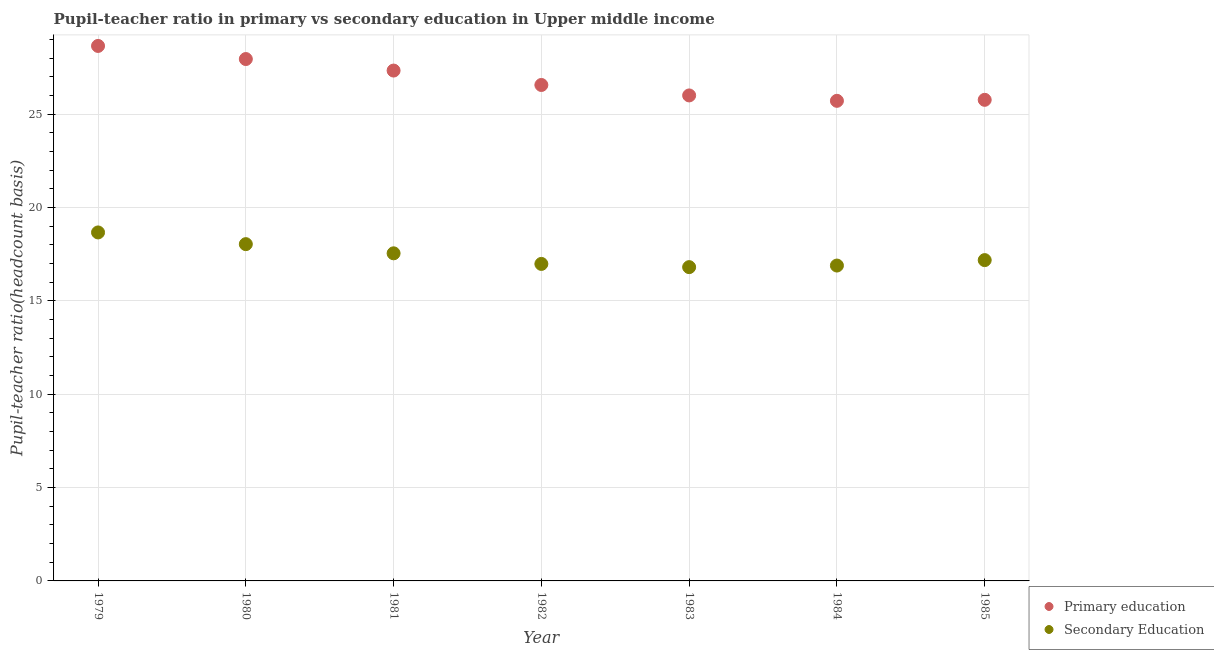How many different coloured dotlines are there?
Your answer should be very brief. 2. Is the number of dotlines equal to the number of legend labels?
Your response must be concise. Yes. What is the pupil-teacher ratio in primary education in 1984?
Keep it short and to the point. 25.72. Across all years, what is the maximum pupil teacher ratio on secondary education?
Your answer should be compact. 18.67. Across all years, what is the minimum pupil teacher ratio on secondary education?
Your answer should be very brief. 16.81. In which year was the pupil-teacher ratio in primary education maximum?
Keep it short and to the point. 1979. In which year was the pupil-teacher ratio in primary education minimum?
Offer a very short reply. 1984. What is the total pupil-teacher ratio in primary education in the graph?
Give a very brief answer. 188. What is the difference between the pupil-teacher ratio in primary education in 1983 and that in 1985?
Provide a short and direct response. 0.24. What is the difference between the pupil teacher ratio on secondary education in 1981 and the pupil-teacher ratio in primary education in 1984?
Make the answer very short. -8.17. What is the average pupil-teacher ratio in primary education per year?
Make the answer very short. 26.86. In the year 1983, what is the difference between the pupil-teacher ratio in primary education and pupil teacher ratio on secondary education?
Make the answer very short. 9.2. In how many years, is the pupil-teacher ratio in primary education greater than 16?
Your answer should be compact. 7. What is the ratio of the pupil-teacher ratio in primary education in 1979 to that in 1982?
Keep it short and to the point. 1.08. Is the pupil teacher ratio on secondary education in 1982 less than that in 1983?
Offer a terse response. No. What is the difference between the highest and the second highest pupil-teacher ratio in primary education?
Make the answer very short. 0.7. What is the difference between the highest and the lowest pupil teacher ratio on secondary education?
Give a very brief answer. 1.86. How many dotlines are there?
Offer a terse response. 2. How many years are there in the graph?
Provide a succinct answer. 7. Does the graph contain grids?
Your answer should be very brief. Yes. Where does the legend appear in the graph?
Offer a very short reply. Bottom right. What is the title of the graph?
Offer a terse response. Pupil-teacher ratio in primary vs secondary education in Upper middle income. What is the label or title of the X-axis?
Ensure brevity in your answer.  Year. What is the label or title of the Y-axis?
Give a very brief answer. Pupil-teacher ratio(headcount basis). What is the Pupil-teacher ratio(headcount basis) of Primary education in 1979?
Offer a terse response. 28.66. What is the Pupil-teacher ratio(headcount basis) in Secondary Education in 1979?
Your response must be concise. 18.67. What is the Pupil-teacher ratio(headcount basis) in Primary education in 1980?
Provide a succinct answer. 27.95. What is the Pupil-teacher ratio(headcount basis) of Secondary Education in 1980?
Keep it short and to the point. 18.04. What is the Pupil-teacher ratio(headcount basis) in Primary education in 1981?
Make the answer very short. 27.34. What is the Pupil-teacher ratio(headcount basis) of Secondary Education in 1981?
Offer a very short reply. 17.55. What is the Pupil-teacher ratio(headcount basis) in Primary education in 1982?
Provide a short and direct response. 26.56. What is the Pupil-teacher ratio(headcount basis) of Secondary Education in 1982?
Keep it short and to the point. 16.98. What is the Pupil-teacher ratio(headcount basis) in Primary education in 1983?
Make the answer very short. 26. What is the Pupil-teacher ratio(headcount basis) of Secondary Education in 1983?
Your answer should be compact. 16.81. What is the Pupil-teacher ratio(headcount basis) in Primary education in 1984?
Give a very brief answer. 25.72. What is the Pupil-teacher ratio(headcount basis) of Secondary Education in 1984?
Your answer should be compact. 16.89. What is the Pupil-teacher ratio(headcount basis) in Primary education in 1985?
Your answer should be very brief. 25.77. What is the Pupil-teacher ratio(headcount basis) in Secondary Education in 1985?
Give a very brief answer. 17.18. Across all years, what is the maximum Pupil-teacher ratio(headcount basis) in Primary education?
Keep it short and to the point. 28.66. Across all years, what is the maximum Pupil-teacher ratio(headcount basis) of Secondary Education?
Offer a very short reply. 18.67. Across all years, what is the minimum Pupil-teacher ratio(headcount basis) of Primary education?
Give a very brief answer. 25.72. Across all years, what is the minimum Pupil-teacher ratio(headcount basis) in Secondary Education?
Keep it short and to the point. 16.81. What is the total Pupil-teacher ratio(headcount basis) in Primary education in the graph?
Provide a short and direct response. 188. What is the total Pupil-teacher ratio(headcount basis) in Secondary Education in the graph?
Your answer should be very brief. 122.12. What is the difference between the Pupil-teacher ratio(headcount basis) in Primary education in 1979 and that in 1980?
Your answer should be compact. 0.7. What is the difference between the Pupil-teacher ratio(headcount basis) in Secondary Education in 1979 and that in 1980?
Keep it short and to the point. 0.63. What is the difference between the Pupil-teacher ratio(headcount basis) of Primary education in 1979 and that in 1981?
Keep it short and to the point. 1.32. What is the difference between the Pupil-teacher ratio(headcount basis) in Secondary Education in 1979 and that in 1981?
Keep it short and to the point. 1.12. What is the difference between the Pupil-teacher ratio(headcount basis) in Primary education in 1979 and that in 1982?
Keep it short and to the point. 2.09. What is the difference between the Pupil-teacher ratio(headcount basis) of Secondary Education in 1979 and that in 1982?
Your answer should be compact. 1.69. What is the difference between the Pupil-teacher ratio(headcount basis) in Primary education in 1979 and that in 1983?
Ensure brevity in your answer.  2.65. What is the difference between the Pupil-teacher ratio(headcount basis) in Secondary Education in 1979 and that in 1983?
Ensure brevity in your answer.  1.86. What is the difference between the Pupil-teacher ratio(headcount basis) of Primary education in 1979 and that in 1984?
Ensure brevity in your answer.  2.94. What is the difference between the Pupil-teacher ratio(headcount basis) in Secondary Education in 1979 and that in 1984?
Make the answer very short. 1.77. What is the difference between the Pupil-teacher ratio(headcount basis) in Primary education in 1979 and that in 1985?
Make the answer very short. 2.89. What is the difference between the Pupil-teacher ratio(headcount basis) of Secondary Education in 1979 and that in 1985?
Offer a very short reply. 1.48. What is the difference between the Pupil-teacher ratio(headcount basis) of Primary education in 1980 and that in 1981?
Make the answer very short. 0.62. What is the difference between the Pupil-teacher ratio(headcount basis) of Secondary Education in 1980 and that in 1981?
Your answer should be very brief. 0.49. What is the difference between the Pupil-teacher ratio(headcount basis) in Primary education in 1980 and that in 1982?
Provide a short and direct response. 1.39. What is the difference between the Pupil-teacher ratio(headcount basis) in Secondary Education in 1980 and that in 1982?
Your response must be concise. 1.06. What is the difference between the Pupil-teacher ratio(headcount basis) of Primary education in 1980 and that in 1983?
Make the answer very short. 1.95. What is the difference between the Pupil-teacher ratio(headcount basis) of Secondary Education in 1980 and that in 1983?
Provide a succinct answer. 1.23. What is the difference between the Pupil-teacher ratio(headcount basis) in Primary education in 1980 and that in 1984?
Provide a succinct answer. 2.24. What is the difference between the Pupil-teacher ratio(headcount basis) of Secondary Education in 1980 and that in 1984?
Your answer should be very brief. 1.15. What is the difference between the Pupil-teacher ratio(headcount basis) of Primary education in 1980 and that in 1985?
Offer a very short reply. 2.18. What is the difference between the Pupil-teacher ratio(headcount basis) in Secondary Education in 1980 and that in 1985?
Provide a short and direct response. 0.86. What is the difference between the Pupil-teacher ratio(headcount basis) in Primary education in 1981 and that in 1982?
Provide a short and direct response. 0.77. What is the difference between the Pupil-teacher ratio(headcount basis) in Secondary Education in 1981 and that in 1982?
Your answer should be very brief. 0.57. What is the difference between the Pupil-teacher ratio(headcount basis) in Primary education in 1981 and that in 1983?
Your answer should be compact. 1.33. What is the difference between the Pupil-teacher ratio(headcount basis) in Secondary Education in 1981 and that in 1983?
Offer a very short reply. 0.74. What is the difference between the Pupil-teacher ratio(headcount basis) of Primary education in 1981 and that in 1984?
Make the answer very short. 1.62. What is the difference between the Pupil-teacher ratio(headcount basis) in Secondary Education in 1981 and that in 1984?
Give a very brief answer. 0.66. What is the difference between the Pupil-teacher ratio(headcount basis) in Primary education in 1981 and that in 1985?
Give a very brief answer. 1.57. What is the difference between the Pupil-teacher ratio(headcount basis) of Secondary Education in 1981 and that in 1985?
Ensure brevity in your answer.  0.36. What is the difference between the Pupil-teacher ratio(headcount basis) of Primary education in 1982 and that in 1983?
Ensure brevity in your answer.  0.56. What is the difference between the Pupil-teacher ratio(headcount basis) of Secondary Education in 1982 and that in 1983?
Keep it short and to the point. 0.17. What is the difference between the Pupil-teacher ratio(headcount basis) of Primary education in 1982 and that in 1984?
Ensure brevity in your answer.  0.85. What is the difference between the Pupil-teacher ratio(headcount basis) of Secondary Education in 1982 and that in 1984?
Offer a very short reply. 0.09. What is the difference between the Pupil-teacher ratio(headcount basis) in Primary education in 1982 and that in 1985?
Your answer should be compact. 0.8. What is the difference between the Pupil-teacher ratio(headcount basis) of Secondary Education in 1982 and that in 1985?
Offer a very short reply. -0.2. What is the difference between the Pupil-teacher ratio(headcount basis) of Primary education in 1983 and that in 1984?
Make the answer very short. 0.29. What is the difference between the Pupil-teacher ratio(headcount basis) in Secondary Education in 1983 and that in 1984?
Provide a short and direct response. -0.08. What is the difference between the Pupil-teacher ratio(headcount basis) of Primary education in 1983 and that in 1985?
Provide a short and direct response. 0.24. What is the difference between the Pupil-teacher ratio(headcount basis) in Secondary Education in 1983 and that in 1985?
Keep it short and to the point. -0.38. What is the difference between the Pupil-teacher ratio(headcount basis) of Primary education in 1984 and that in 1985?
Make the answer very short. -0.05. What is the difference between the Pupil-teacher ratio(headcount basis) of Secondary Education in 1984 and that in 1985?
Your answer should be very brief. -0.29. What is the difference between the Pupil-teacher ratio(headcount basis) of Primary education in 1979 and the Pupil-teacher ratio(headcount basis) of Secondary Education in 1980?
Your answer should be very brief. 10.62. What is the difference between the Pupil-teacher ratio(headcount basis) in Primary education in 1979 and the Pupil-teacher ratio(headcount basis) in Secondary Education in 1981?
Ensure brevity in your answer.  11.11. What is the difference between the Pupil-teacher ratio(headcount basis) of Primary education in 1979 and the Pupil-teacher ratio(headcount basis) of Secondary Education in 1982?
Your response must be concise. 11.68. What is the difference between the Pupil-teacher ratio(headcount basis) of Primary education in 1979 and the Pupil-teacher ratio(headcount basis) of Secondary Education in 1983?
Your answer should be compact. 11.85. What is the difference between the Pupil-teacher ratio(headcount basis) in Primary education in 1979 and the Pupil-teacher ratio(headcount basis) in Secondary Education in 1984?
Ensure brevity in your answer.  11.76. What is the difference between the Pupil-teacher ratio(headcount basis) in Primary education in 1979 and the Pupil-teacher ratio(headcount basis) in Secondary Education in 1985?
Provide a short and direct response. 11.47. What is the difference between the Pupil-teacher ratio(headcount basis) in Primary education in 1980 and the Pupil-teacher ratio(headcount basis) in Secondary Education in 1981?
Give a very brief answer. 10.41. What is the difference between the Pupil-teacher ratio(headcount basis) in Primary education in 1980 and the Pupil-teacher ratio(headcount basis) in Secondary Education in 1982?
Keep it short and to the point. 10.97. What is the difference between the Pupil-teacher ratio(headcount basis) in Primary education in 1980 and the Pupil-teacher ratio(headcount basis) in Secondary Education in 1983?
Offer a very short reply. 11.15. What is the difference between the Pupil-teacher ratio(headcount basis) in Primary education in 1980 and the Pupil-teacher ratio(headcount basis) in Secondary Education in 1984?
Provide a succinct answer. 11.06. What is the difference between the Pupil-teacher ratio(headcount basis) in Primary education in 1980 and the Pupil-teacher ratio(headcount basis) in Secondary Education in 1985?
Offer a very short reply. 10.77. What is the difference between the Pupil-teacher ratio(headcount basis) of Primary education in 1981 and the Pupil-teacher ratio(headcount basis) of Secondary Education in 1982?
Provide a succinct answer. 10.36. What is the difference between the Pupil-teacher ratio(headcount basis) in Primary education in 1981 and the Pupil-teacher ratio(headcount basis) in Secondary Education in 1983?
Offer a very short reply. 10.53. What is the difference between the Pupil-teacher ratio(headcount basis) of Primary education in 1981 and the Pupil-teacher ratio(headcount basis) of Secondary Education in 1984?
Offer a very short reply. 10.44. What is the difference between the Pupil-teacher ratio(headcount basis) of Primary education in 1981 and the Pupil-teacher ratio(headcount basis) of Secondary Education in 1985?
Offer a terse response. 10.15. What is the difference between the Pupil-teacher ratio(headcount basis) of Primary education in 1982 and the Pupil-teacher ratio(headcount basis) of Secondary Education in 1983?
Provide a short and direct response. 9.76. What is the difference between the Pupil-teacher ratio(headcount basis) in Primary education in 1982 and the Pupil-teacher ratio(headcount basis) in Secondary Education in 1984?
Your answer should be compact. 9.67. What is the difference between the Pupil-teacher ratio(headcount basis) of Primary education in 1982 and the Pupil-teacher ratio(headcount basis) of Secondary Education in 1985?
Keep it short and to the point. 9.38. What is the difference between the Pupil-teacher ratio(headcount basis) in Primary education in 1983 and the Pupil-teacher ratio(headcount basis) in Secondary Education in 1984?
Your answer should be compact. 9.11. What is the difference between the Pupil-teacher ratio(headcount basis) in Primary education in 1983 and the Pupil-teacher ratio(headcount basis) in Secondary Education in 1985?
Ensure brevity in your answer.  8.82. What is the difference between the Pupil-teacher ratio(headcount basis) in Primary education in 1984 and the Pupil-teacher ratio(headcount basis) in Secondary Education in 1985?
Give a very brief answer. 8.53. What is the average Pupil-teacher ratio(headcount basis) of Primary education per year?
Your answer should be very brief. 26.86. What is the average Pupil-teacher ratio(headcount basis) in Secondary Education per year?
Ensure brevity in your answer.  17.45. In the year 1979, what is the difference between the Pupil-teacher ratio(headcount basis) in Primary education and Pupil-teacher ratio(headcount basis) in Secondary Education?
Provide a succinct answer. 9.99. In the year 1980, what is the difference between the Pupil-teacher ratio(headcount basis) in Primary education and Pupil-teacher ratio(headcount basis) in Secondary Education?
Keep it short and to the point. 9.91. In the year 1981, what is the difference between the Pupil-teacher ratio(headcount basis) of Primary education and Pupil-teacher ratio(headcount basis) of Secondary Education?
Your answer should be compact. 9.79. In the year 1982, what is the difference between the Pupil-teacher ratio(headcount basis) in Primary education and Pupil-teacher ratio(headcount basis) in Secondary Education?
Offer a terse response. 9.59. In the year 1983, what is the difference between the Pupil-teacher ratio(headcount basis) of Primary education and Pupil-teacher ratio(headcount basis) of Secondary Education?
Your answer should be very brief. 9.2. In the year 1984, what is the difference between the Pupil-teacher ratio(headcount basis) in Primary education and Pupil-teacher ratio(headcount basis) in Secondary Education?
Keep it short and to the point. 8.82. In the year 1985, what is the difference between the Pupil-teacher ratio(headcount basis) of Primary education and Pupil-teacher ratio(headcount basis) of Secondary Education?
Your answer should be compact. 8.59. What is the ratio of the Pupil-teacher ratio(headcount basis) in Primary education in 1979 to that in 1980?
Your answer should be very brief. 1.03. What is the ratio of the Pupil-teacher ratio(headcount basis) of Secondary Education in 1979 to that in 1980?
Provide a short and direct response. 1.03. What is the ratio of the Pupil-teacher ratio(headcount basis) of Primary education in 1979 to that in 1981?
Provide a succinct answer. 1.05. What is the ratio of the Pupil-teacher ratio(headcount basis) of Secondary Education in 1979 to that in 1981?
Provide a short and direct response. 1.06. What is the ratio of the Pupil-teacher ratio(headcount basis) of Primary education in 1979 to that in 1982?
Give a very brief answer. 1.08. What is the ratio of the Pupil-teacher ratio(headcount basis) of Secondary Education in 1979 to that in 1982?
Offer a terse response. 1.1. What is the ratio of the Pupil-teacher ratio(headcount basis) in Primary education in 1979 to that in 1983?
Offer a very short reply. 1.1. What is the ratio of the Pupil-teacher ratio(headcount basis) of Secondary Education in 1979 to that in 1983?
Provide a succinct answer. 1.11. What is the ratio of the Pupil-teacher ratio(headcount basis) of Primary education in 1979 to that in 1984?
Ensure brevity in your answer.  1.11. What is the ratio of the Pupil-teacher ratio(headcount basis) in Secondary Education in 1979 to that in 1984?
Your answer should be compact. 1.1. What is the ratio of the Pupil-teacher ratio(headcount basis) of Primary education in 1979 to that in 1985?
Your answer should be compact. 1.11. What is the ratio of the Pupil-teacher ratio(headcount basis) in Secondary Education in 1979 to that in 1985?
Provide a succinct answer. 1.09. What is the ratio of the Pupil-teacher ratio(headcount basis) in Primary education in 1980 to that in 1981?
Offer a very short reply. 1.02. What is the ratio of the Pupil-teacher ratio(headcount basis) of Secondary Education in 1980 to that in 1981?
Keep it short and to the point. 1.03. What is the ratio of the Pupil-teacher ratio(headcount basis) in Primary education in 1980 to that in 1982?
Your answer should be very brief. 1.05. What is the ratio of the Pupil-teacher ratio(headcount basis) of Secondary Education in 1980 to that in 1982?
Make the answer very short. 1.06. What is the ratio of the Pupil-teacher ratio(headcount basis) in Primary education in 1980 to that in 1983?
Your response must be concise. 1.07. What is the ratio of the Pupil-teacher ratio(headcount basis) of Secondary Education in 1980 to that in 1983?
Ensure brevity in your answer.  1.07. What is the ratio of the Pupil-teacher ratio(headcount basis) of Primary education in 1980 to that in 1984?
Give a very brief answer. 1.09. What is the ratio of the Pupil-teacher ratio(headcount basis) of Secondary Education in 1980 to that in 1984?
Ensure brevity in your answer.  1.07. What is the ratio of the Pupil-teacher ratio(headcount basis) of Primary education in 1980 to that in 1985?
Ensure brevity in your answer.  1.08. What is the ratio of the Pupil-teacher ratio(headcount basis) in Secondary Education in 1980 to that in 1985?
Give a very brief answer. 1.05. What is the ratio of the Pupil-teacher ratio(headcount basis) of Primary education in 1981 to that in 1982?
Your answer should be compact. 1.03. What is the ratio of the Pupil-teacher ratio(headcount basis) of Secondary Education in 1981 to that in 1982?
Ensure brevity in your answer.  1.03. What is the ratio of the Pupil-teacher ratio(headcount basis) in Primary education in 1981 to that in 1983?
Your answer should be compact. 1.05. What is the ratio of the Pupil-teacher ratio(headcount basis) of Secondary Education in 1981 to that in 1983?
Keep it short and to the point. 1.04. What is the ratio of the Pupil-teacher ratio(headcount basis) in Primary education in 1981 to that in 1984?
Provide a short and direct response. 1.06. What is the ratio of the Pupil-teacher ratio(headcount basis) in Secondary Education in 1981 to that in 1984?
Provide a succinct answer. 1.04. What is the ratio of the Pupil-teacher ratio(headcount basis) in Primary education in 1981 to that in 1985?
Make the answer very short. 1.06. What is the ratio of the Pupil-teacher ratio(headcount basis) of Secondary Education in 1981 to that in 1985?
Provide a succinct answer. 1.02. What is the ratio of the Pupil-teacher ratio(headcount basis) of Primary education in 1982 to that in 1983?
Your answer should be very brief. 1.02. What is the ratio of the Pupil-teacher ratio(headcount basis) of Secondary Education in 1982 to that in 1983?
Your answer should be very brief. 1.01. What is the ratio of the Pupil-teacher ratio(headcount basis) in Primary education in 1982 to that in 1984?
Make the answer very short. 1.03. What is the ratio of the Pupil-teacher ratio(headcount basis) of Secondary Education in 1982 to that in 1984?
Offer a very short reply. 1.01. What is the ratio of the Pupil-teacher ratio(headcount basis) of Primary education in 1982 to that in 1985?
Your response must be concise. 1.03. What is the ratio of the Pupil-teacher ratio(headcount basis) of Primary education in 1983 to that in 1984?
Your response must be concise. 1.01. What is the ratio of the Pupil-teacher ratio(headcount basis) in Secondary Education in 1983 to that in 1984?
Ensure brevity in your answer.  0.99. What is the ratio of the Pupil-teacher ratio(headcount basis) of Primary education in 1983 to that in 1985?
Keep it short and to the point. 1.01. What is the ratio of the Pupil-teacher ratio(headcount basis) of Secondary Education in 1983 to that in 1985?
Offer a terse response. 0.98. What is the ratio of the Pupil-teacher ratio(headcount basis) of Primary education in 1984 to that in 1985?
Offer a terse response. 1. What is the ratio of the Pupil-teacher ratio(headcount basis) of Secondary Education in 1984 to that in 1985?
Make the answer very short. 0.98. What is the difference between the highest and the second highest Pupil-teacher ratio(headcount basis) of Primary education?
Ensure brevity in your answer.  0.7. What is the difference between the highest and the second highest Pupil-teacher ratio(headcount basis) in Secondary Education?
Give a very brief answer. 0.63. What is the difference between the highest and the lowest Pupil-teacher ratio(headcount basis) of Primary education?
Your answer should be very brief. 2.94. What is the difference between the highest and the lowest Pupil-teacher ratio(headcount basis) of Secondary Education?
Keep it short and to the point. 1.86. 